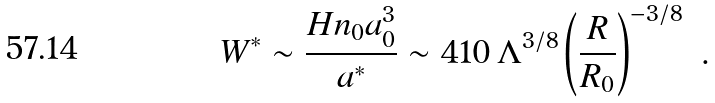Convert formula to latex. <formula><loc_0><loc_0><loc_500><loc_500>W ^ { \ast } \sim \frac { H n _ { 0 } a _ { 0 } ^ { 3 } } { a ^ { \ast } } \sim 4 1 0 \, \Lambda ^ { 3 / 8 } \left ( \frac { R } { R _ { 0 } } \right ) ^ { - 3 / 8 } \ .</formula> 